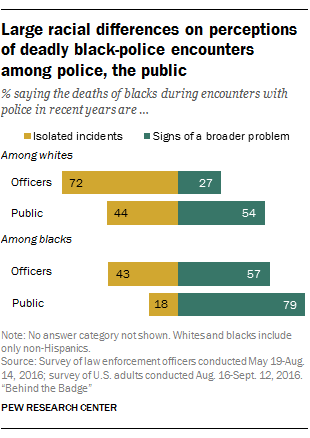Mention a couple of crucial points in this snapshot. The difference between the highest and lowest green bar in the graph is 52. The lowest value of the green bar is 27. 